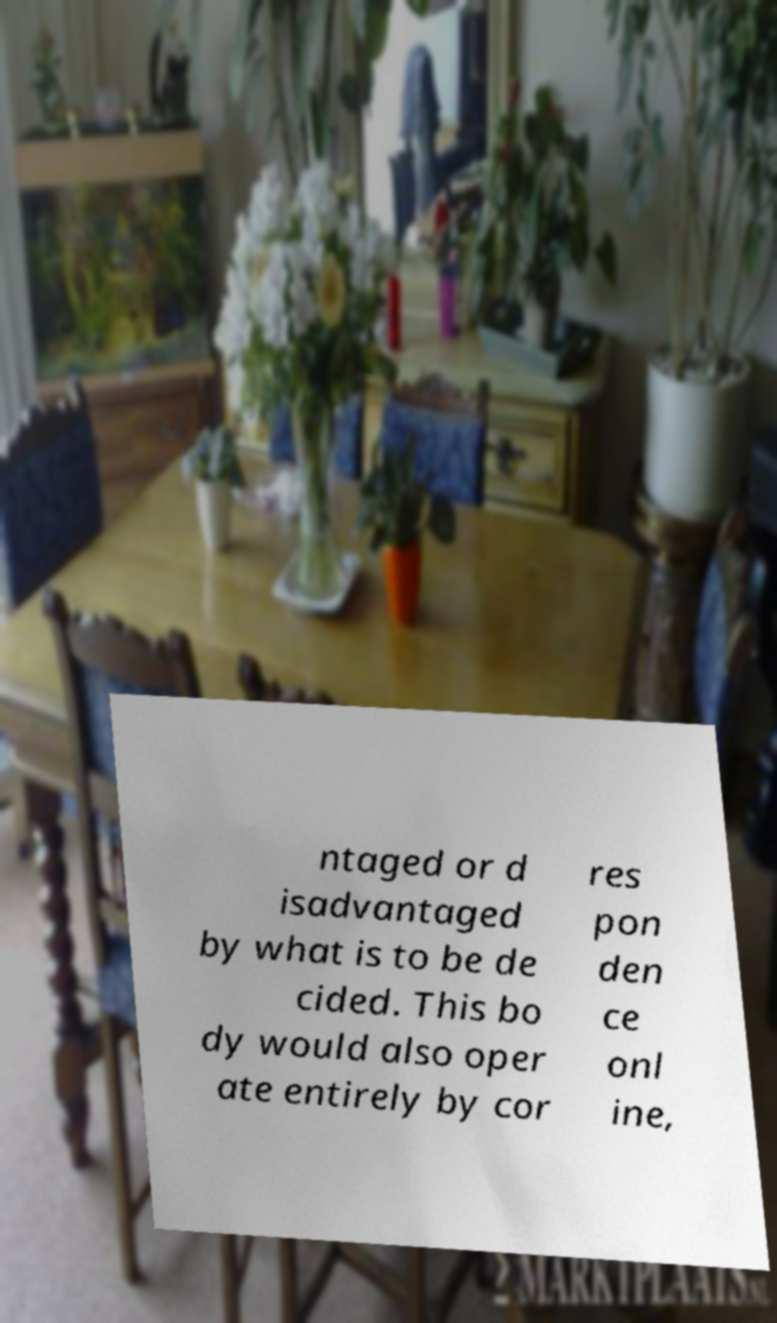Can you accurately transcribe the text from the provided image for me? ntaged or d isadvantaged by what is to be de cided. This bo dy would also oper ate entirely by cor res pon den ce onl ine, 